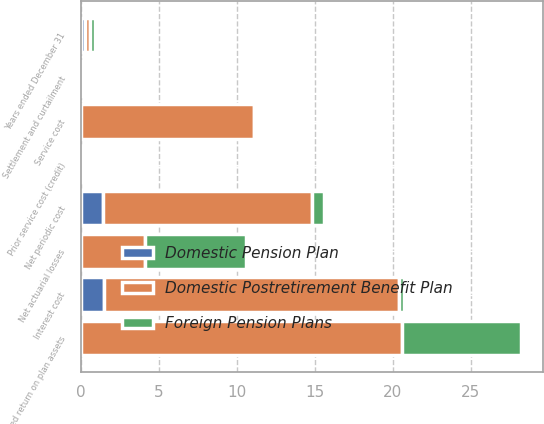Convert chart to OTSL. <chart><loc_0><loc_0><loc_500><loc_500><stacked_bar_chart><ecel><fcel>Years ended December 31<fcel>Service cost<fcel>Interest cost<fcel>Expected return on plan assets<fcel>Settlement and curtailment<fcel>Prior service cost (credit)<fcel>Net actuarial losses<fcel>Net periodic cost<nl><fcel>Foreign Pension Plans<fcel>0.3<fcel>0<fcel>0.3<fcel>7.6<fcel>0<fcel>0<fcel>6.5<fcel>0.8<nl><fcel>Domestic Postretirement Benefit Plan<fcel>0.3<fcel>11.1<fcel>18.9<fcel>20.6<fcel>0.2<fcel>0.1<fcel>4.1<fcel>13.4<nl><fcel>Domestic Pension Plan<fcel>0.3<fcel>0<fcel>1.5<fcel>0<fcel>0<fcel>0.1<fcel>0<fcel>1.4<nl></chart> 